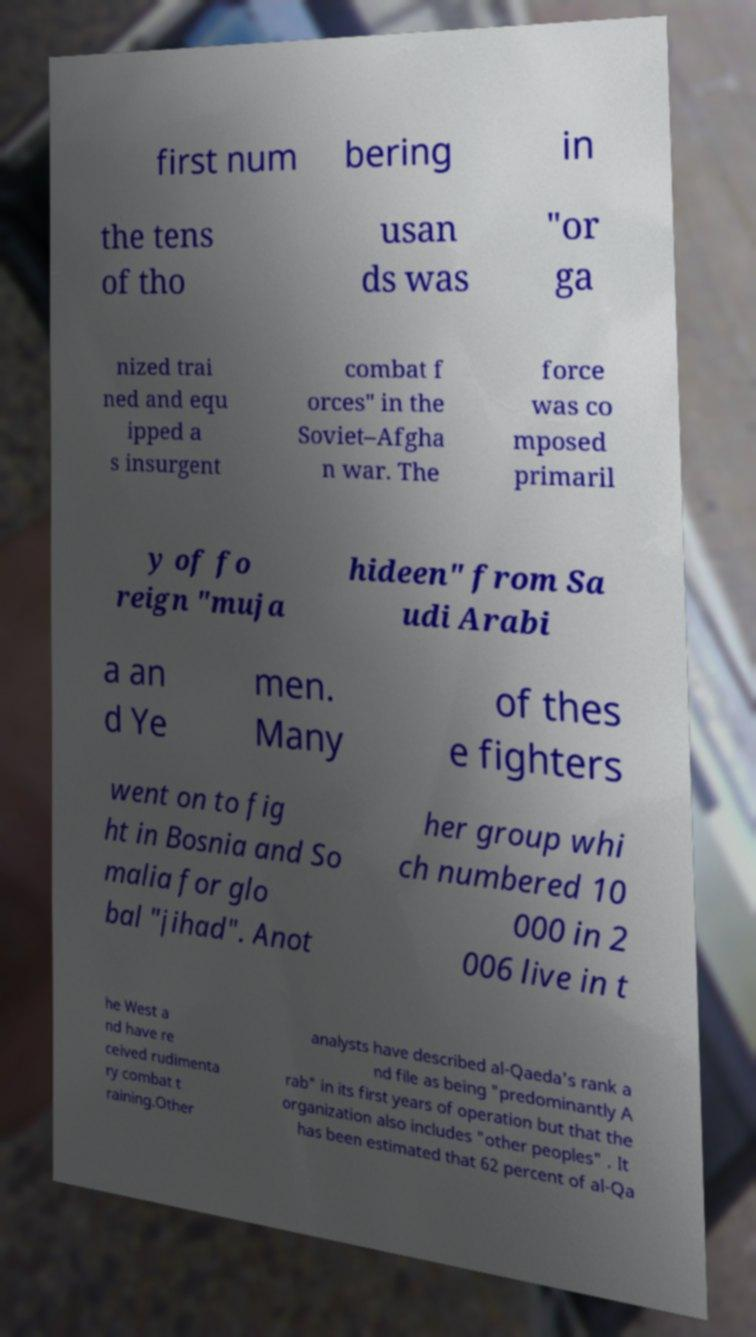Could you extract and type out the text from this image? first num bering in the tens of tho usan ds was "or ga nized trai ned and equ ipped a s insurgent combat f orces" in the Soviet–Afgha n war. The force was co mposed primaril y of fo reign "muja hideen" from Sa udi Arabi a an d Ye men. Many of thes e fighters went on to fig ht in Bosnia and So malia for glo bal "jihad". Anot her group whi ch numbered 10 000 in 2 006 live in t he West a nd have re ceived rudimenta ry combat t raining.Other analysts have described al-Qaeda's rank a nd file as being "predominantly A rab" in its first years of operation but that the organization also includes "other peoples" . It has been estimated that 62 percent of al-Qa 